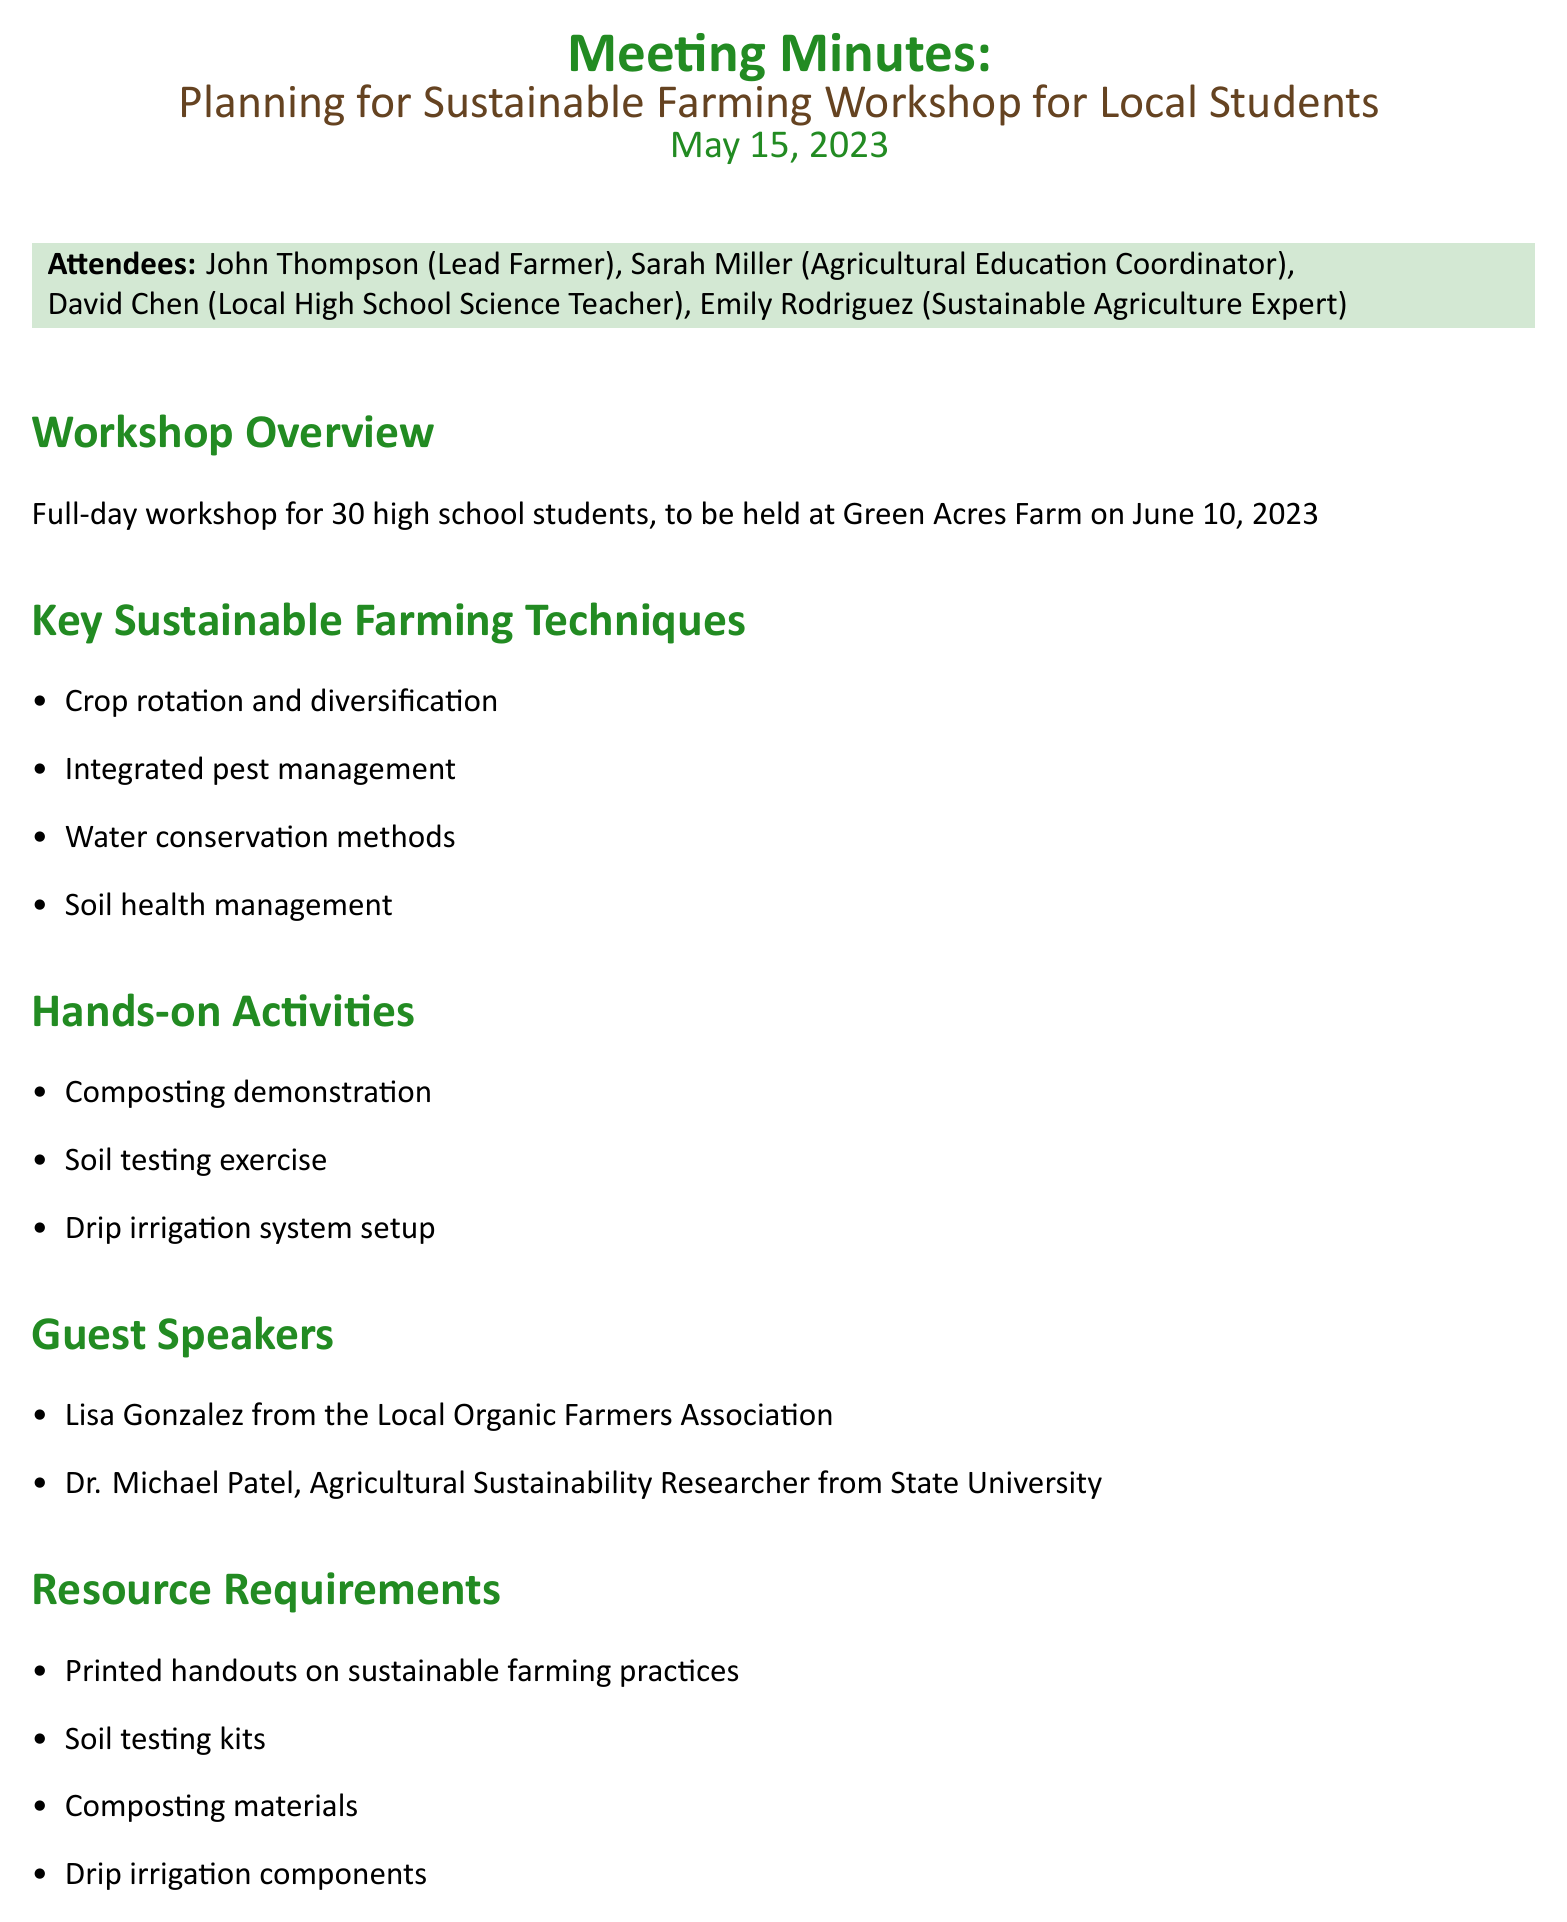what is the date of the workshop? The workshop is scheduled to be held on June 10, 2023, as stated in the workshop overview.
Answer: June 10, 2023 how many students will attend? The workshop is planned for 30 high school students, as mentioned in the workshop overview.
Answer: 30 who is the lead farmer? The lead farmer's name is listed as John Thompson in the attendees section.
Answer: John Thompson what are the hands-on activities? The document lists several hands-on activities, including a composting demonstration, soil testing exercise, and drip irrigation system setup.
Answer: Composting demonstration, Soil testing exercise, Drip irrigation system setup who is responsible for handling student registrations? The document states that David is tasked with handling student registrations and permissions under action items.
Answer: David what type of resource is required for soil testing? The resource required specifically for soil testing is mentioned as soil testing kits in the resource requirements section.
Answer: Soil testing kits who will coordinate with guest speakers? According to the action items, John is responsible for coordinating with guest speakers.
Answer: John what is one follow-up plan after the workshop? The document lists several follow-up plans, one of which is a mentorship program with local farmers.
Answer: Mentorship program with local farmers what is the role of Sarah Miller? Sarah Miller is described as the Agricultural Education Coordinator in the attendees list and is tasked with preparing workshop materials.
Answer: Agricultural Education Coordinator 